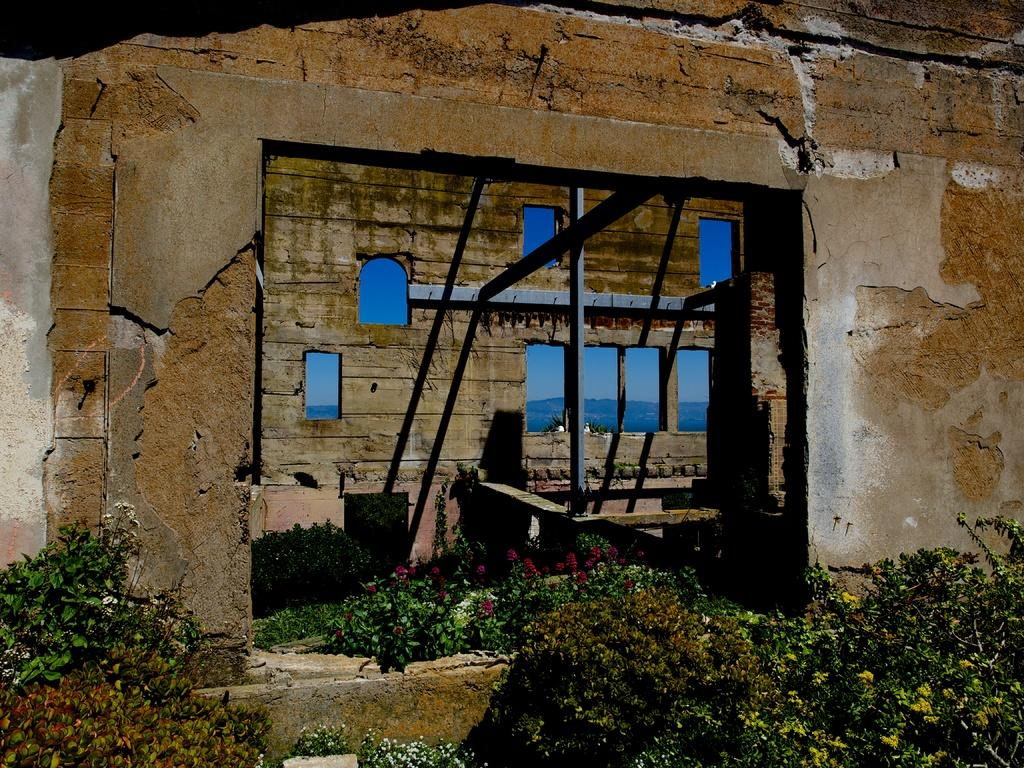What types of vegetation can be seen in the foreground of the image? There are plants and flowers in the foreground of the image. What structure is located in the middle of the image? There is a wall in the middle of the image. What type of natural feature is visible in the background of the image? There is a mountain in the background of the image. What type of behavior can be observed in the birds in the image? There are no birds present in the image, so their behavior cannot be observed. How comfortable is the mountain in the image? The image does not provide information about the comfort of the mountain, as it is a natural feature and not a living being. 